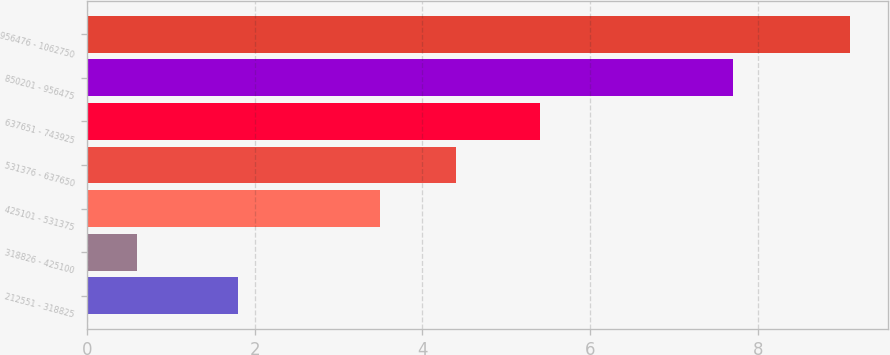Convert chart. <chart><loc_0><loc_0><loc_500><loc_500><bar_chart><fcel>212551 - 318825<fcel>318826 - 425100<fcel>425101 - 531375<fcel>531376 - 637650<fcel>637651 - 743925<fcel>850201 - 956475<fcel>956476 - 1062750<nl><fcel>1.8<fcel>0.6<fcel>3.5<fcel>4.4<fcel>5.4<fcel>7.7<fcel>9.1<nl></chart> 